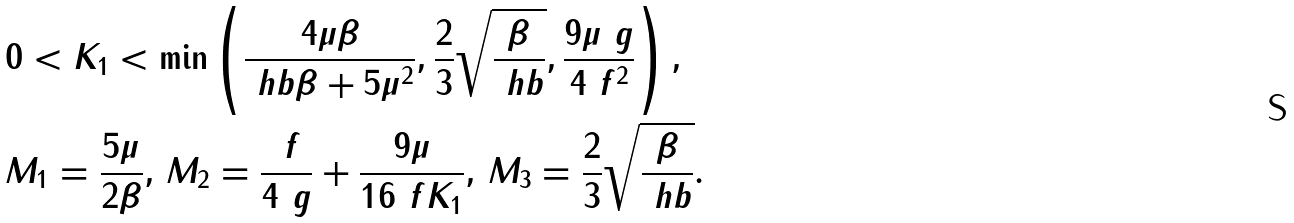<formula> <loc_0><loc_0><loc_500><loc_500>& 0 < K _ { 1 } < \min \left ( \frac { 4 \mu \beta } { \ h b \beta + 5 \mu ^ { 2 } } , \frac { 2 } { 3 } \sqrt { \frac { \beta } { \ h b } } , \frac { 9 \mu \ g } { 4 \ f ^ { 2 } } \right ) , \\ & M _ { 1 } = \frac { 5 \mu } { 2 \beta } , \, M _ { 2 } = \frac { \ f } { 4 \ g } + \frac { 9 \mu } { 1 6 \ f K _ { 1 } } , \, M _ { 3 } = \frac { 2 } { 3 } \sqrt { \frac { \beta } { \ h b } } .</formula> 